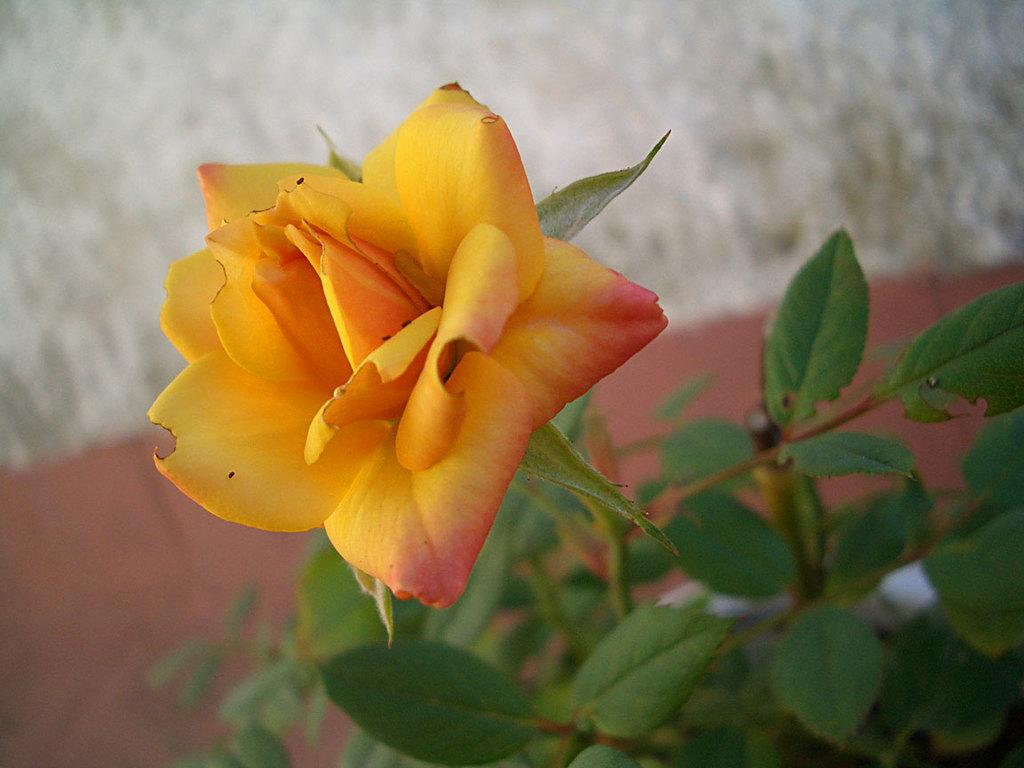What type of plant is visible in the image? There is a flower in the image. What other part of the plant can be seen in the image? There are leaves in the image. How would you describe the background of the image? The background of the image is blurry. How many degrees does the cat have in the image? There is no cat present in the image, so it is not possible to determine the degrees it might have. 